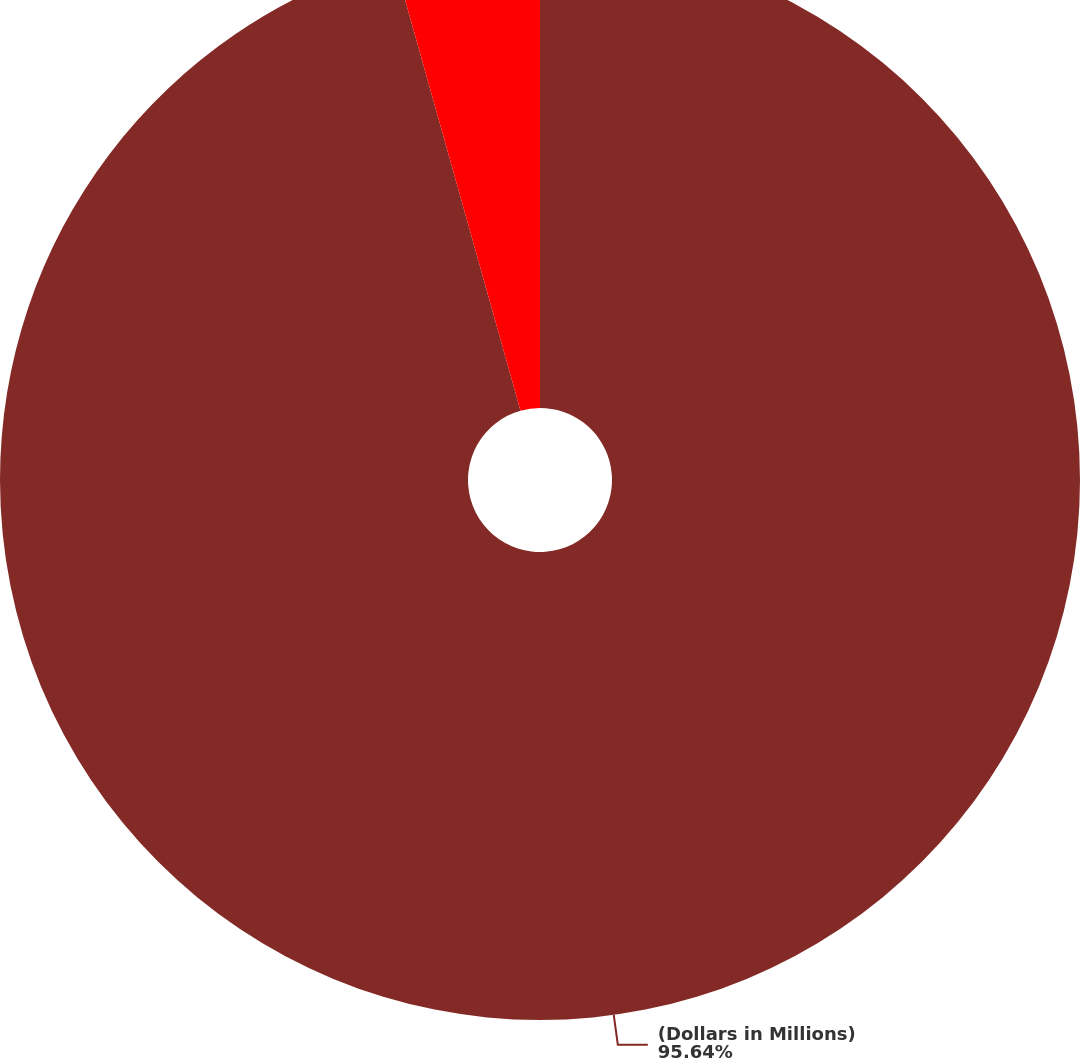Convert chart. <chart><loc_0><loc_0><loc_500><loc_500><pie_chart><fcel>(Dollars in Millions)<fcel>Projected future contributions<nl><fcel>95.64%<fcel>4.36%<nl></chart> 